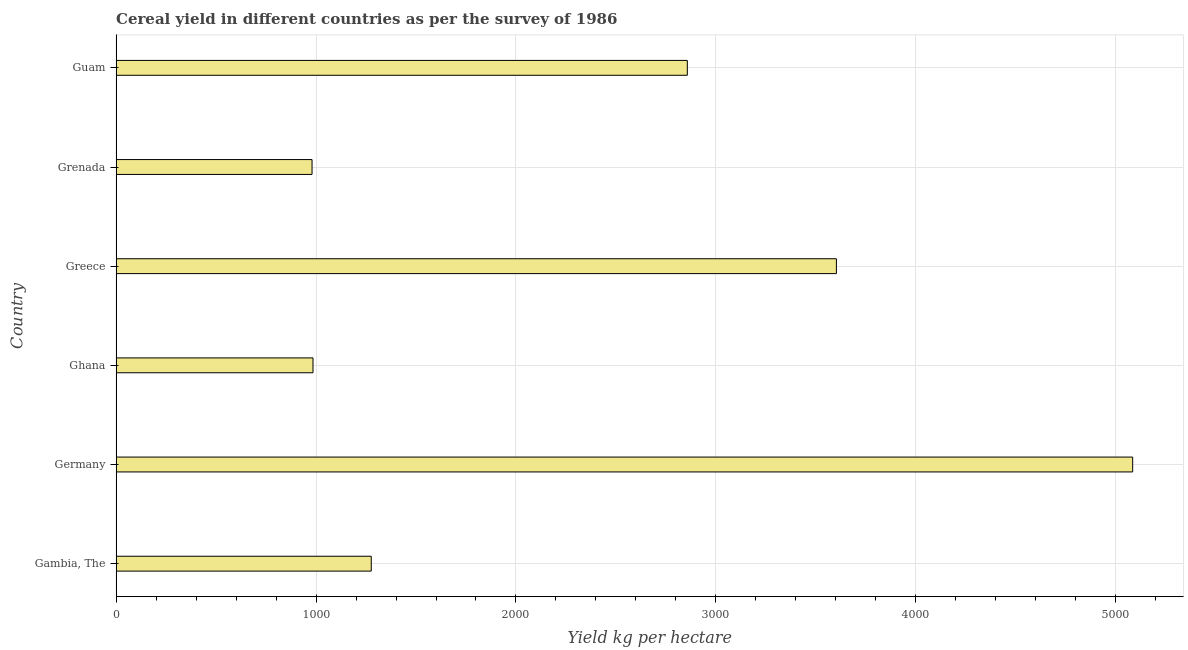Does the graph contain any zero values?
Provide a succinct answer. No. What is the title of the graph?
Your response must be concise. Cereal yield in different countries as per the survey of 1986. What is the label or title of the X-axis?
Your answer should be compact. Yield kg per hectare. What is the label or title of the Y-axis?
Give a very brief answer. Country. What is the cereal yield in Greece?
Give a very brief answer. 3602.85. Across all countries, what is the maximum cereal yield?
Provide a short and direct response. 5084.8. Across all countries, what is the minimum cereal yield?
Provide a succinct answer. 980. In which country was the cereal yield maximum?
Ensure brevity in your answer.  Germany. In which country was the cereal yield minimum?
Your response must be concise. Grenada. What is the sum of the cereal yield?
Your response must be concise. 1.48e+04. What is the difference between the cereal yield in Ghana and Greece?
Ensure brevity in your answer.  -2618.07. What is the average cereal yield per country?
Your answer should be very brief. 2464.3. What is the median cereal yield?
Ensure brevity in your answer.  2066.69. What is the ratio of the cereal yield in Gambia, The to that in Grenada?
Give a very brief answer. 1.3. What is the difference between the highest and the second highest cereal yield?
Provide a short and direct response. 1481.95. Is the sum of the cereal yield in Grenada and Guam greater than the maximum cereal yield across all countries?
Your answer should be compact. No. What is the difference between the highest and the lowest cereal yield?
Make the answer very short. 4104.8. How many bars are there?
Provide a succinct answer. 6. How many countries are there in the graph?
Give a very brief answer. 6. What is the difference between two consecutive major ticks on the X-axis?
Offer a very short reply. 1000. What is the Yield kg per hectare in Gambia, The?
Offer a very short reply. 1276.23. What is the Yield kg per hectare of Germany?
Make the answer very short. 5084.8. What is the Yield kg per hectare of Ghana?
Provide a short and direct response. 984.77. What is the Yield kg per hectare in Greece?
Your answer should be very brief. 3602.85. What is the Yield kg per hectare of Grenada?
Make the answer very short. 980. What is the Yield kg per hectare of Guam?
Provide a succinct answer. 2857.14. What is the difference between the Yield kg per hectare in Gambia, The and Germany?
Keep it short and to the point. -3808.57. What is the difference between the Yield kg per hectare in Gambia, The and Ghana?
Your response must be concise. 291.45. What is the difference between the Yield kg per hectare in Gambia, The and Greece?
Give a very brief answer. -2326.62. What is the difference between the Yield kg per hectare in Gambia, The and Grenada?
Your response must be concise. 296.23. What is the difference between the Yield kg per hectare in Gambia, The and Guam?
Give a very brief answer. -1580.91. What is the difference between the Yield kg per hectare in Germany and Ghana?
Ensure brevity in your answer.  4100.02. What is the difference between the Yield kg per hectare in Germany and Greece?
Offer a very short reply. 1481.95. What is the difference between the Yield kg per hectare in Germany and Grenada?
Ensure brevity in your answer.  4104.8. What is the difference between the Yield kg per hectare in Germany and Guam?
Offer a terse response. 2227.66. What is the difference between the Yield kg per hectare in Ghana and Greece?
Keep it short and to the point. -2618.07. What is the difference between the Yield kg per hectare in Ghana and Grenada?
Your answer should be very brief. 4.77. What is the difference between the Yield kg per hectare in Ghana and Guam?
Keep it short and to the point. -1872.37. What is the difference between the Yield kg per hectare in Greece and Grenada?
Offer a very short reply. 2622.85. What is the difference between the Yield kg per hectare in Greece and Guam?
Provide a short and direct response. 745.7. What is the difference between the Yield kg per hectare in Grenada and Guam?
Offer a very short reply. -1877.14. What is the ratio of the Yield kg per hectare in Gambia, The to that in Germany?
Offer a terse response. 0.25. What is the ratio of the Yield kg per hectare in Gambia, The to that in Ghana?
Provide a short and direct response. 1.3. What is the ratio of the Yield kg per hectare in Gambia, The to that in Greece?
Your answer should be compact. 0.35. What is the ratio of the Yield kg per hectare in Gambia, The to that in Grenada?
Offer a very short reply. 1.3. What is the ratio of the Yield kg per hectare in Gambia, The to that in Guam?
Make the answer very short. 0.45. What is the ratio of the Yield kg per hectare in Germany to that in Ghana?
Keep it short and to the point. 5.16. What is the ratio of the Yield kg per hectare in Germany to that in Greece?
Make the answer very short. 1.41. What is the ratio of the Yield kg per hectare in Germany to that in Grenada?
Your answer should be very brief. 5.19. What is the ratio of the Yield kg per hectare in Germany to that in Guam?
Your response must be concise. 1.78. What is the ratio of the Yield kg per hectare in Ghana to that in Greece?
Provide a succinct answer. 0.27. What is the ratio of the Yield kg per hectare in Ghana to that in Grenada?
Ensure brevity in your answer.  1. What is the ratio of the Yield kg per hectare in Ghana to that in Guam?
Provide a succinct answer. 0.34. What is the ratio of the Yield kg per hectare in Greece to that in Grenada?
Provide a short and direct response. 3.68. What is the ratio of the Yield kg per hectare in Greece to that in Guam?
Make the answer very short. 1.26. What is the ratio of the Yield kg per hectare in Grenada to that in Guam?
Offer a terse response. 0.34. 